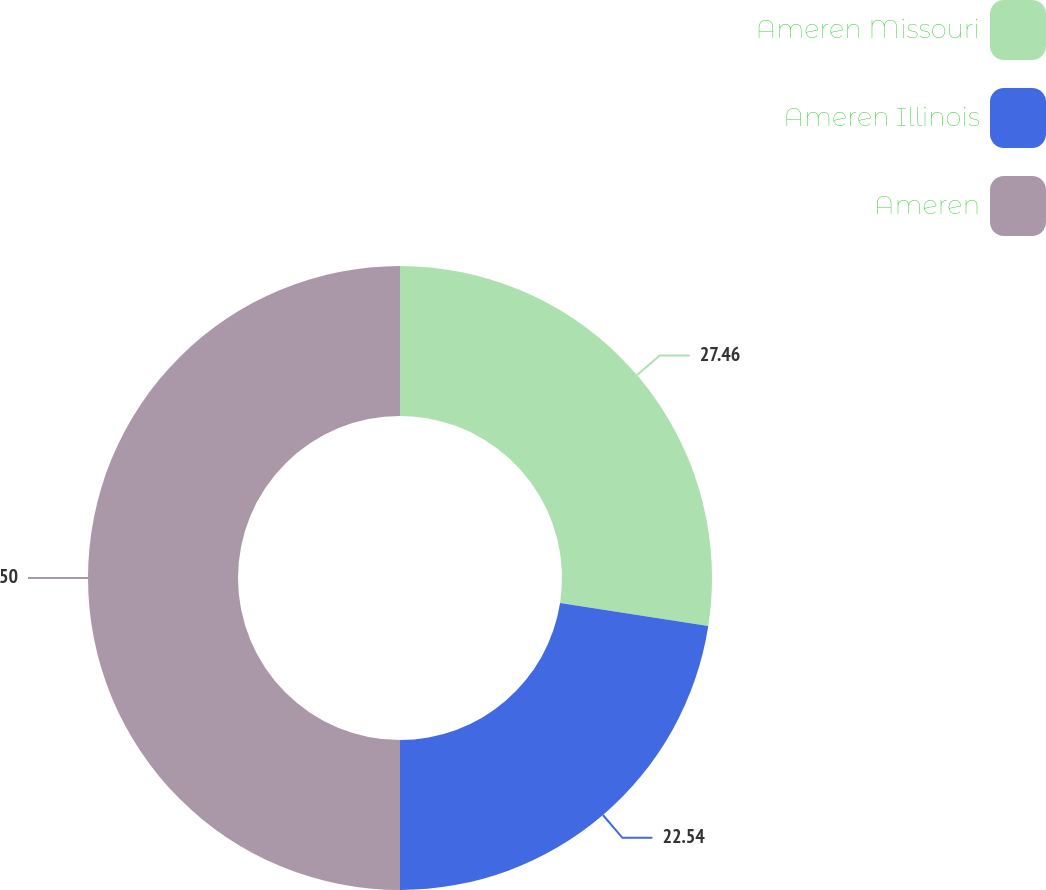Convert chart. <chart><loc_0><loc_0><loc_500><loc_500><pie_chart><fcel>Ameren Missouri<fcel>Ameren Illinois<fcel>Ameren<nl><fcel>27.46%<fcel>22.54%<fcel>50.0%<nl></chart> 